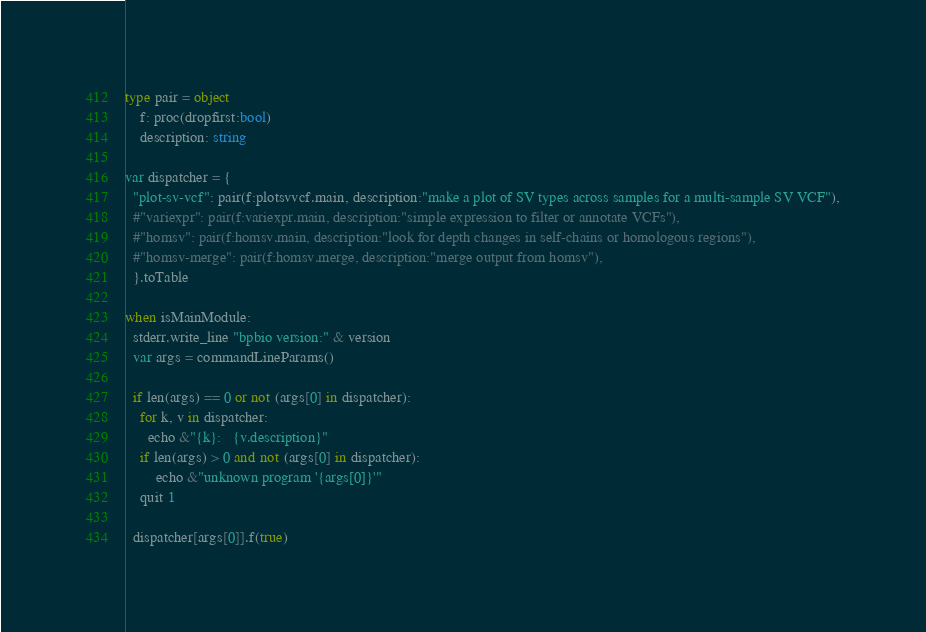Convert code to text. <code><loc_0><loc_0><loc_500><loc_500><_Nim_>
type pair = object
    f: proc(dropfirst:bool)
    description: string

var dispatcher = {
  "plot-sv-vcf": pair(f:plotsvvcf.main, description:"make a plot of SV types across samples for a multi-sample SV VCF"),
  #"variexpr": pair(f:variexpr.main, description:"simple expression to filter or annotate VCFs"),
  #"homsv": pair(f:homsv.main, description:"look for depth changes in self-chains or homologous regions"),
  #"homsv-merge": pair(f:homsv.merge, description:"merge output from homsv"),
  }.toTable

when isMainModule:
  stderr.write_line "bpbio version:" & version
  var args = commandLineParams()

  if len(args) == 0 or not (args[0] in dispatcher):
    for k, v in dispatcher:
      echo &"{k}:   {v.description}"
    if len(args) > 0 and not (args[0] in dispatcher):
        echo &"unknown program '{args[0]}'"
    quit 1

  dispatcher[args[0]].f(true)
</code> 